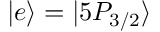Convert formula to latex. <formula><loc_0><loc_0><loc_500><loc_500>| e \rangle = | 5 P _ { 3 / 2 } \rangle</formula> 